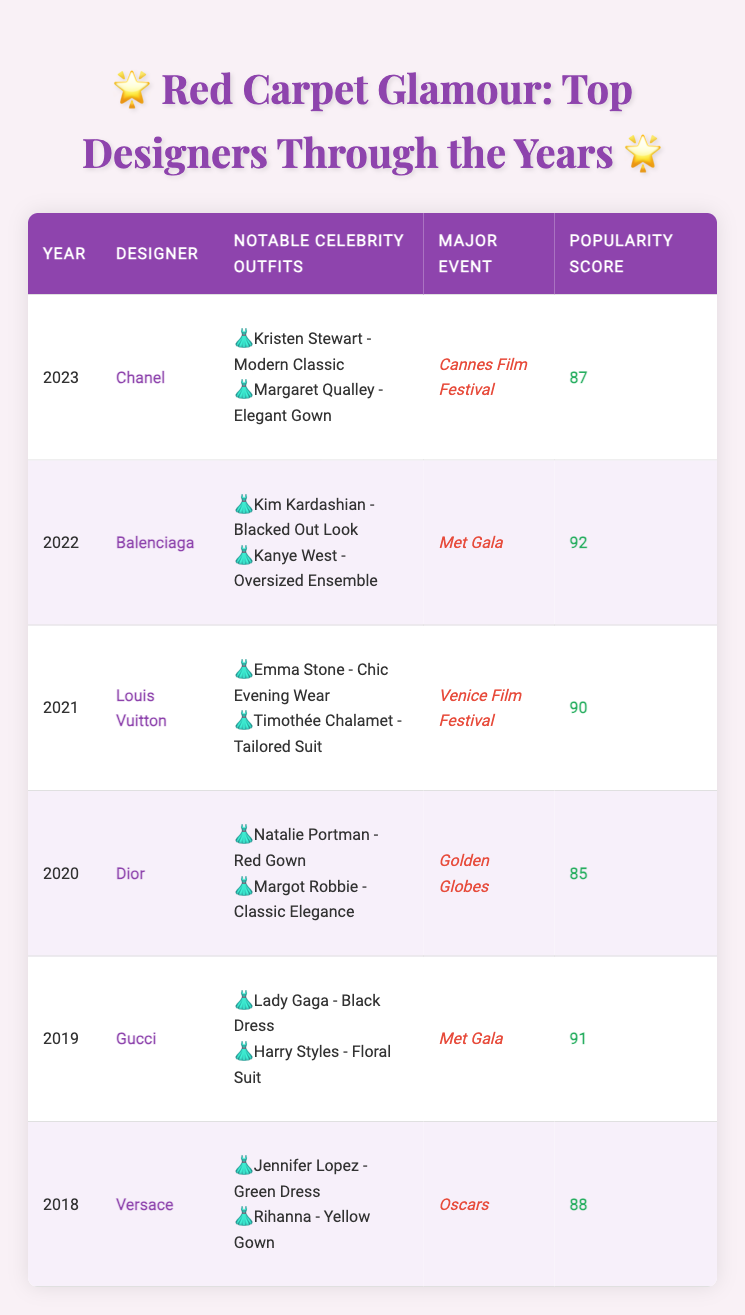What designer had the highest popularity score in the years listed? By reviewing the "Popularity Score" column, Balenciaga, in 2022, has the highest value of 92, compared to the other designers in the table.
Answer: Balenciaga Which designer had notable celebrity outfits for the Met Gala? The designers associated with the Met Gala are Gucci in 2019 and Balenciaga in 2022, based on the "Major Event" column.
Answer: Gucci and Balenciaga What is the average popularity score of the designers from 2018 to 2020? The scores for 2018, 2019, and 2020 are 88, 91, and 85, respectively. Adding these gives 88 + 91 + 85 = 264, and dividing by 3 gives an average of 264 / 3 = 88.
Answer: 88 Did any designer have their notable celebrity outfits showcased at both the Oscars and the Met Gala? Examining the "Major Event" column, Versace was featured at the Oscars in 2018 and Gucci was featured at the Met Gala in 2019. Thus, no single designer was showcased at both events.
Answer: No Which year saw the designer Louis Vuitton and what were the notable outfits? Louis Vuitton appeared in 2021, as listed in the Year column. The notable outfits were "Emma Stone - Chic Evening Wear" and "Timothée Chalamet - Tailored Suit," which can be found in the notable outfits section.
Answer: 2021: Emma Stone - Chic Evening Wear, Timothée Chalamet - Tailored Suit 